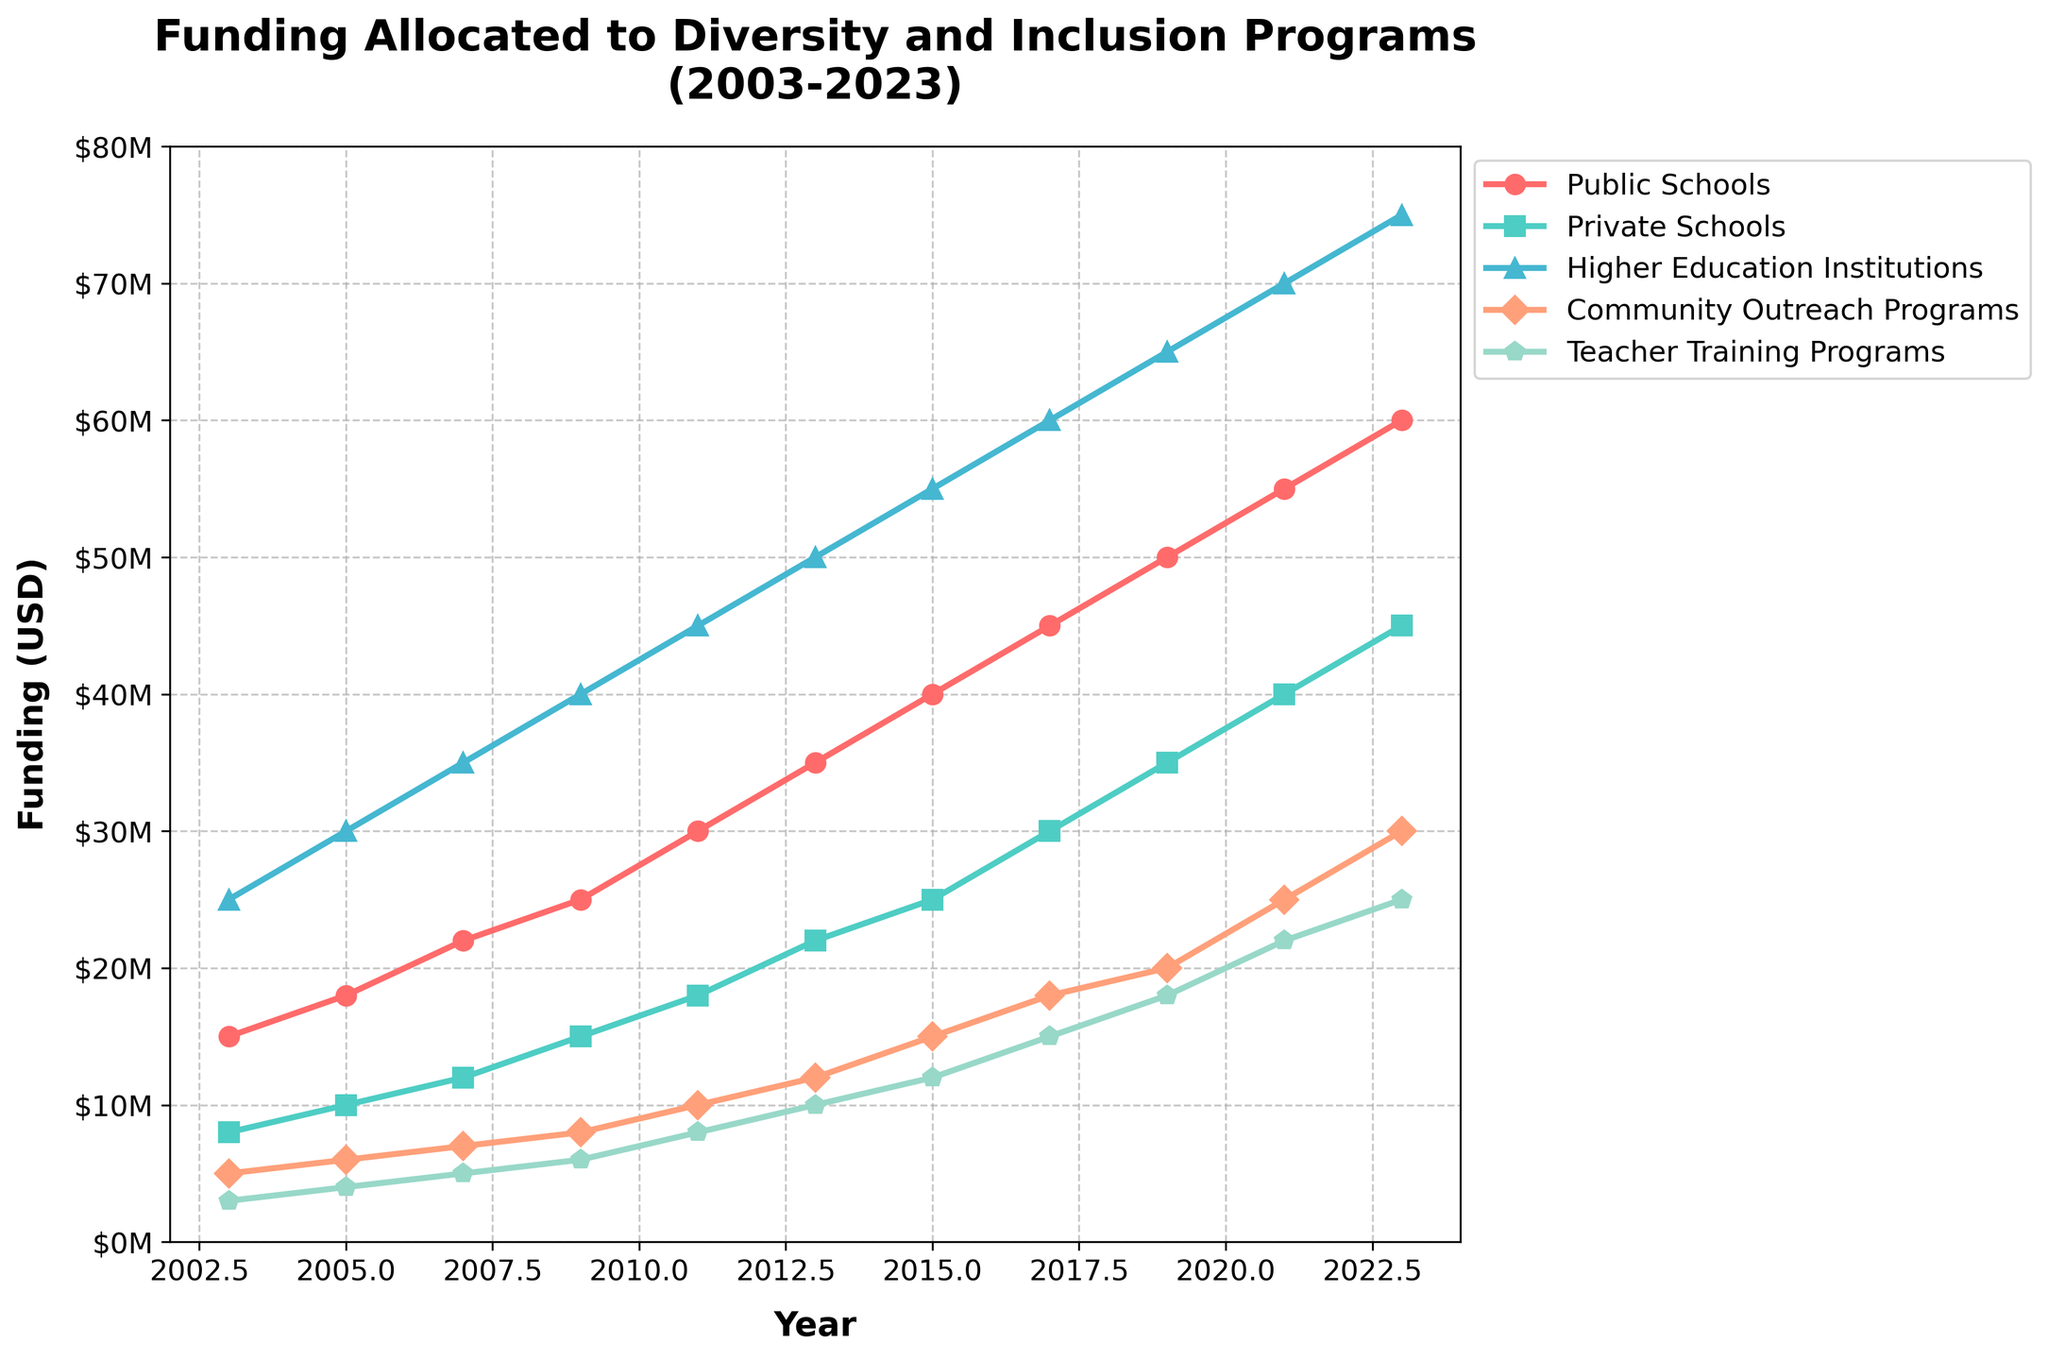Which funding category has the highest allocation in 2023? By looking at the rightmost side of the chart for 2023, the line that reaches the highest value represents the 'Higher Education Institutions' category.
Answer: Higher Education Institutions How much has the funding for Community Outreach Programs increased from 2003 to 2023? In 2003, the funding for Community Outreach Programs is $5,000,000. In 2023, it is $30,000,000. The increase is $30,000,000 - $5,000,000 = $25,000,000.
Answer: $25,000,000 Which category saw the highest growth in funding from 2003 to 2023? To find the highest growth, calculate the difference between 2003 and 2023 funding for each category. Higher Education Institutions grew by $75,000,000 - $25,000,000 = $50,000,000, which is the highest growth among all categories.
Answer: Higher Education Institutions What is the total funding allocated to Private Schools and Teacher Training Programs in 2011? The funding for Private Schools in 2011 is $18,000,000, and for Teacher Training Programs, it is $8,000,000. The total is $18,000,000 + $8,000,000 = $26,000,000.
Answer: $26,000,000 Compare the funding trends of Public Schools and Private Schools from 2003 to 2023. Which one saw a steeper increase? From 2003 to 2023, funding for Public Schools increased from $15,000,000 to $60,000,000, an increase of $45,000,000. Private Schools increased from $8,000,000 to $45,000,000, an increase of $37,000,000. Therefore, Public Schools saw a steeper increase.
Answer: Public Schools What was the average funding allocated to Teacher Training Programs over the entire period? Sum of funding values for Teacher Training Programs from 2003 to 2023: $3,000,000 + $4,000,000 + $5,000,000 + $6,000,000 + $8,000,000 + $10,000,000 + $12,000,000 + $15,000,000 + $18,000,000 + $22,000,000 + $25,000,000 = $128,000,000. The period is 11 years, so average funding is $128,000,000 / 11 ≈ $11,636,364.
Answer: $11,636,364 What is the difference in funding between Public Schools and Community Outreach Programs in 2017? The funding for Public Schools in 2017 is $45,000,000, and for Community Outreach Programs, it is $18,000,000. The difference is $45,000,000 - $18,000,000 = $27,000,000.
Answer: $27,000,000 Which category consistently received funding increases every given year from 2003 to 2023? By following each line/funding trajectory for 2003 to 2023, we see that all the categories ('Public Schools', 'Private Schools', 'Higher Education Institutions', 'Community Outreach Programs', 'Teacher Training Programs') show a consistent increase every given year.
Answer: All categories 